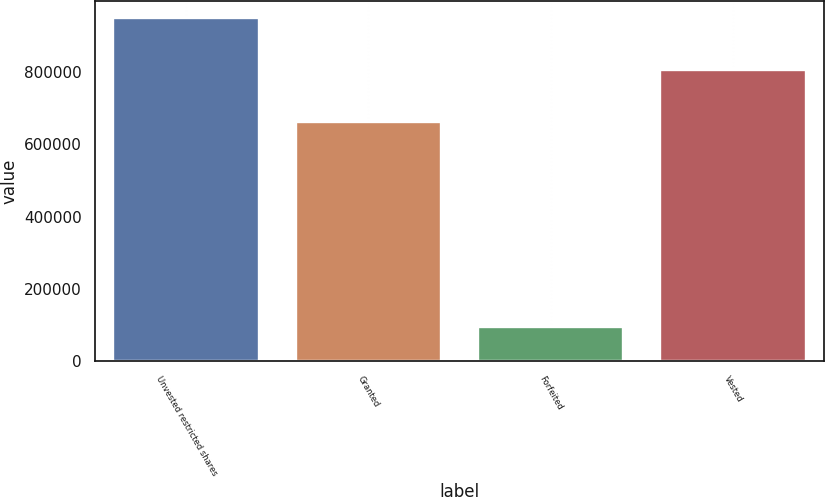Convert chart. <chart><loc_0><loc_0><loc_500><loc_500><bar_chart><fcel>Unvested restricted shares<fcel>Granted<fcel>Forfeited<fcel>Vested<nl><fcel>948120<fcel>660617<fcel>95700<fcel>804368<nl></chart> 